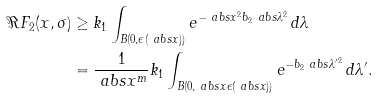Convert formula to latex. <formula><loc_0><loc_0><loc_500><loc_500>\Re { F _ { 2 } ( x , \sigma ) } & \geq k _ { 1 } \int _ { B ( 0 , \epsilon ( \ a b s { x } ) ) } e ^ { - \ a b s { x } ^ { 2 } b _ { 2 } \ a b s { \lambda } ^ { 2 } } \, d \lambda \\ & = \frac { 1 } { \ a b s { x } ^ { m } } k _ { 1 } \int _ { B ( 0 , \ a b s { x } \epsilon ( \ a b s { x } ) ) } e ^ { - b _ { 2 } \ a b s { \lambda ^ { \prime } } ^ { 2 } } \, d \lambda ^ { \prime } .</formula> 